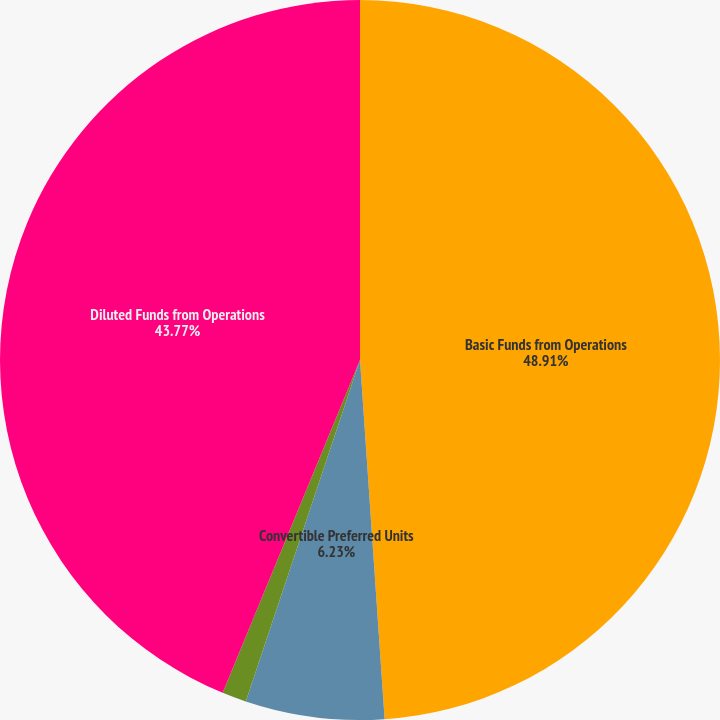<chart> <loc_0><loc_0><loc_500><loc_500><pie_chart><fcel>Basic Funds from Operations<fcel>Convertible Preferred Units<fcel>Convertible Preferred Stock<fcel>Diluted Funds from Operations<nl><fcel>48.91%<fcel>6.23%<fcel>1.09%<fcel>43.77%<nl></chart> 